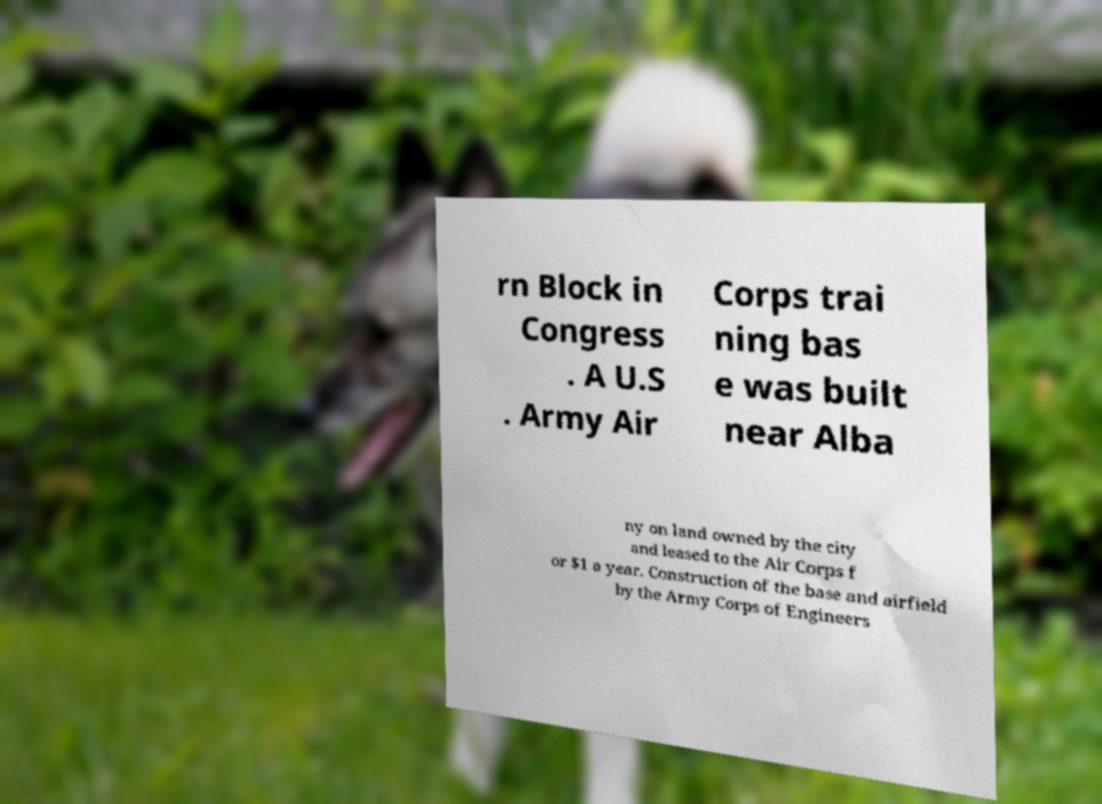Can you read and provide the text displayed in the image?This photo seems to have some interesting text. Can you extract and type it out for me? rn Block in Congress . A U.S . Army Air Corps trai ning bas e was built near Alba ny on land owned by the city and leased to the Air Corps f or $1 a year. Construction of the base and airfield by the Army Corps of Engineers 